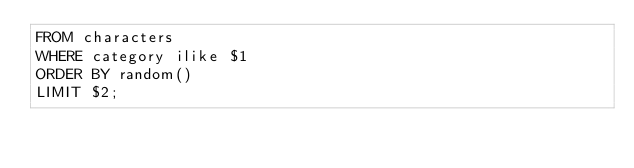Convert code to text. <code><loc_0><loc_0><loc_500><loc_500><_SQL_>FROM characters
WHERE category ilike $1
ORDER BY random()
LIMIT $2;</code> 